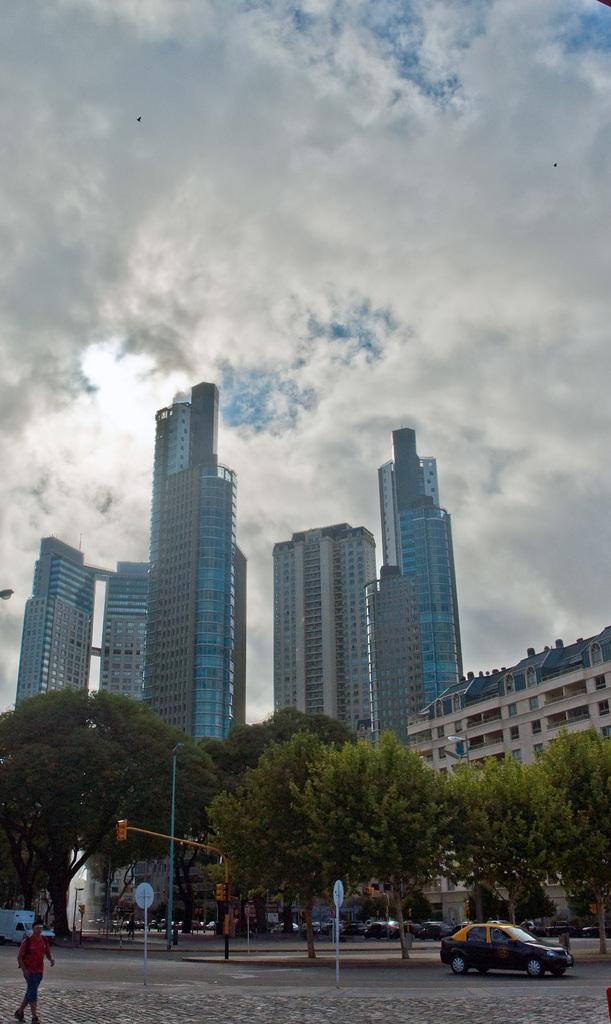Could you give a brief overview of what you see in this image? In the background we can see the clouds in the sky. In this picture we can see buildings, traffic signals, poles, lights, boards, trees and vehicles. On the left side of the picture we can see a person is walking. 